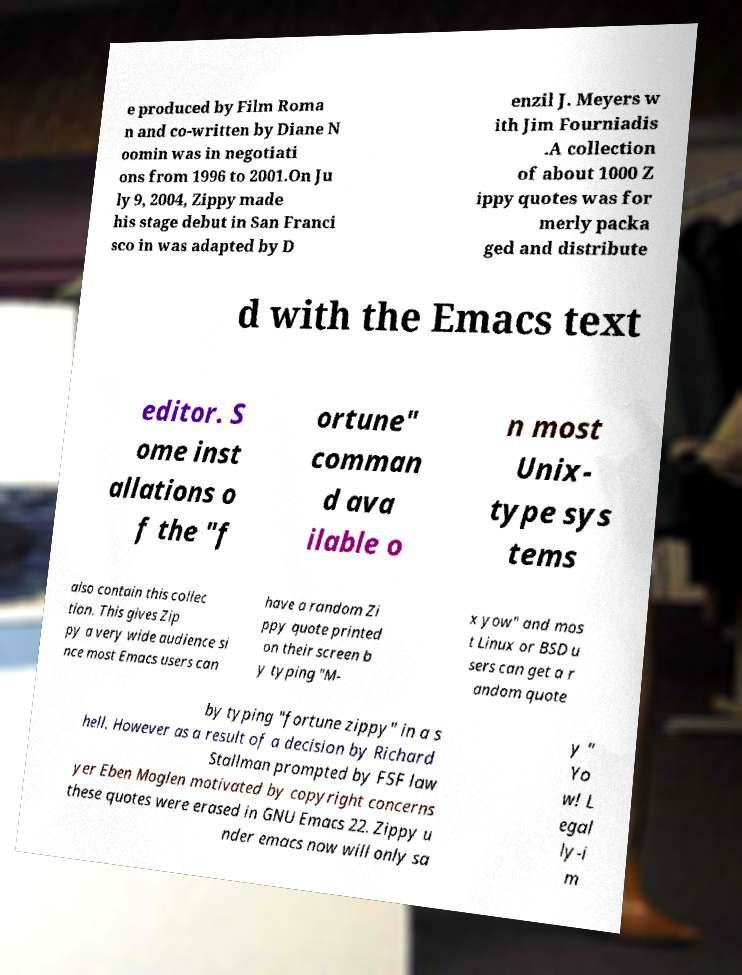Please identify and transcribe the text found in this image. e produced by Film Roma n and co-written by Diane N oomin was in negotiati ons from 1996 to 2001.On Ju ly 9, 2004, Zippy made his stage debut in San Franci sco in was adapted by D enzil J. Meyers w ith Jim Fourniadis .A collection of about 1000 Z ippy quotes was for merly packa ged and distribute d with the Emacs text editor. S ome inst allations o f the "f ortune" comman d ava ilable o n most Unix- type sys tems also contain this collec tion. This gives Zip py a very wide audience si nce most Emacs users can have a random Zi ppy quote printed on their screen b y typing "M- x yow" and mos t Linux or BSD u sers can get a r andom quote by typing "fortune zippy" in a s hell. However as a result of a decision by Richard Stallman prompted by FSF law yer Eben Moglen motivated by copyright concerns these quotes were erased in GNU Emacs 22. Zippy u nder emacs now will only sa y " Yo w! L egal ly-i m 